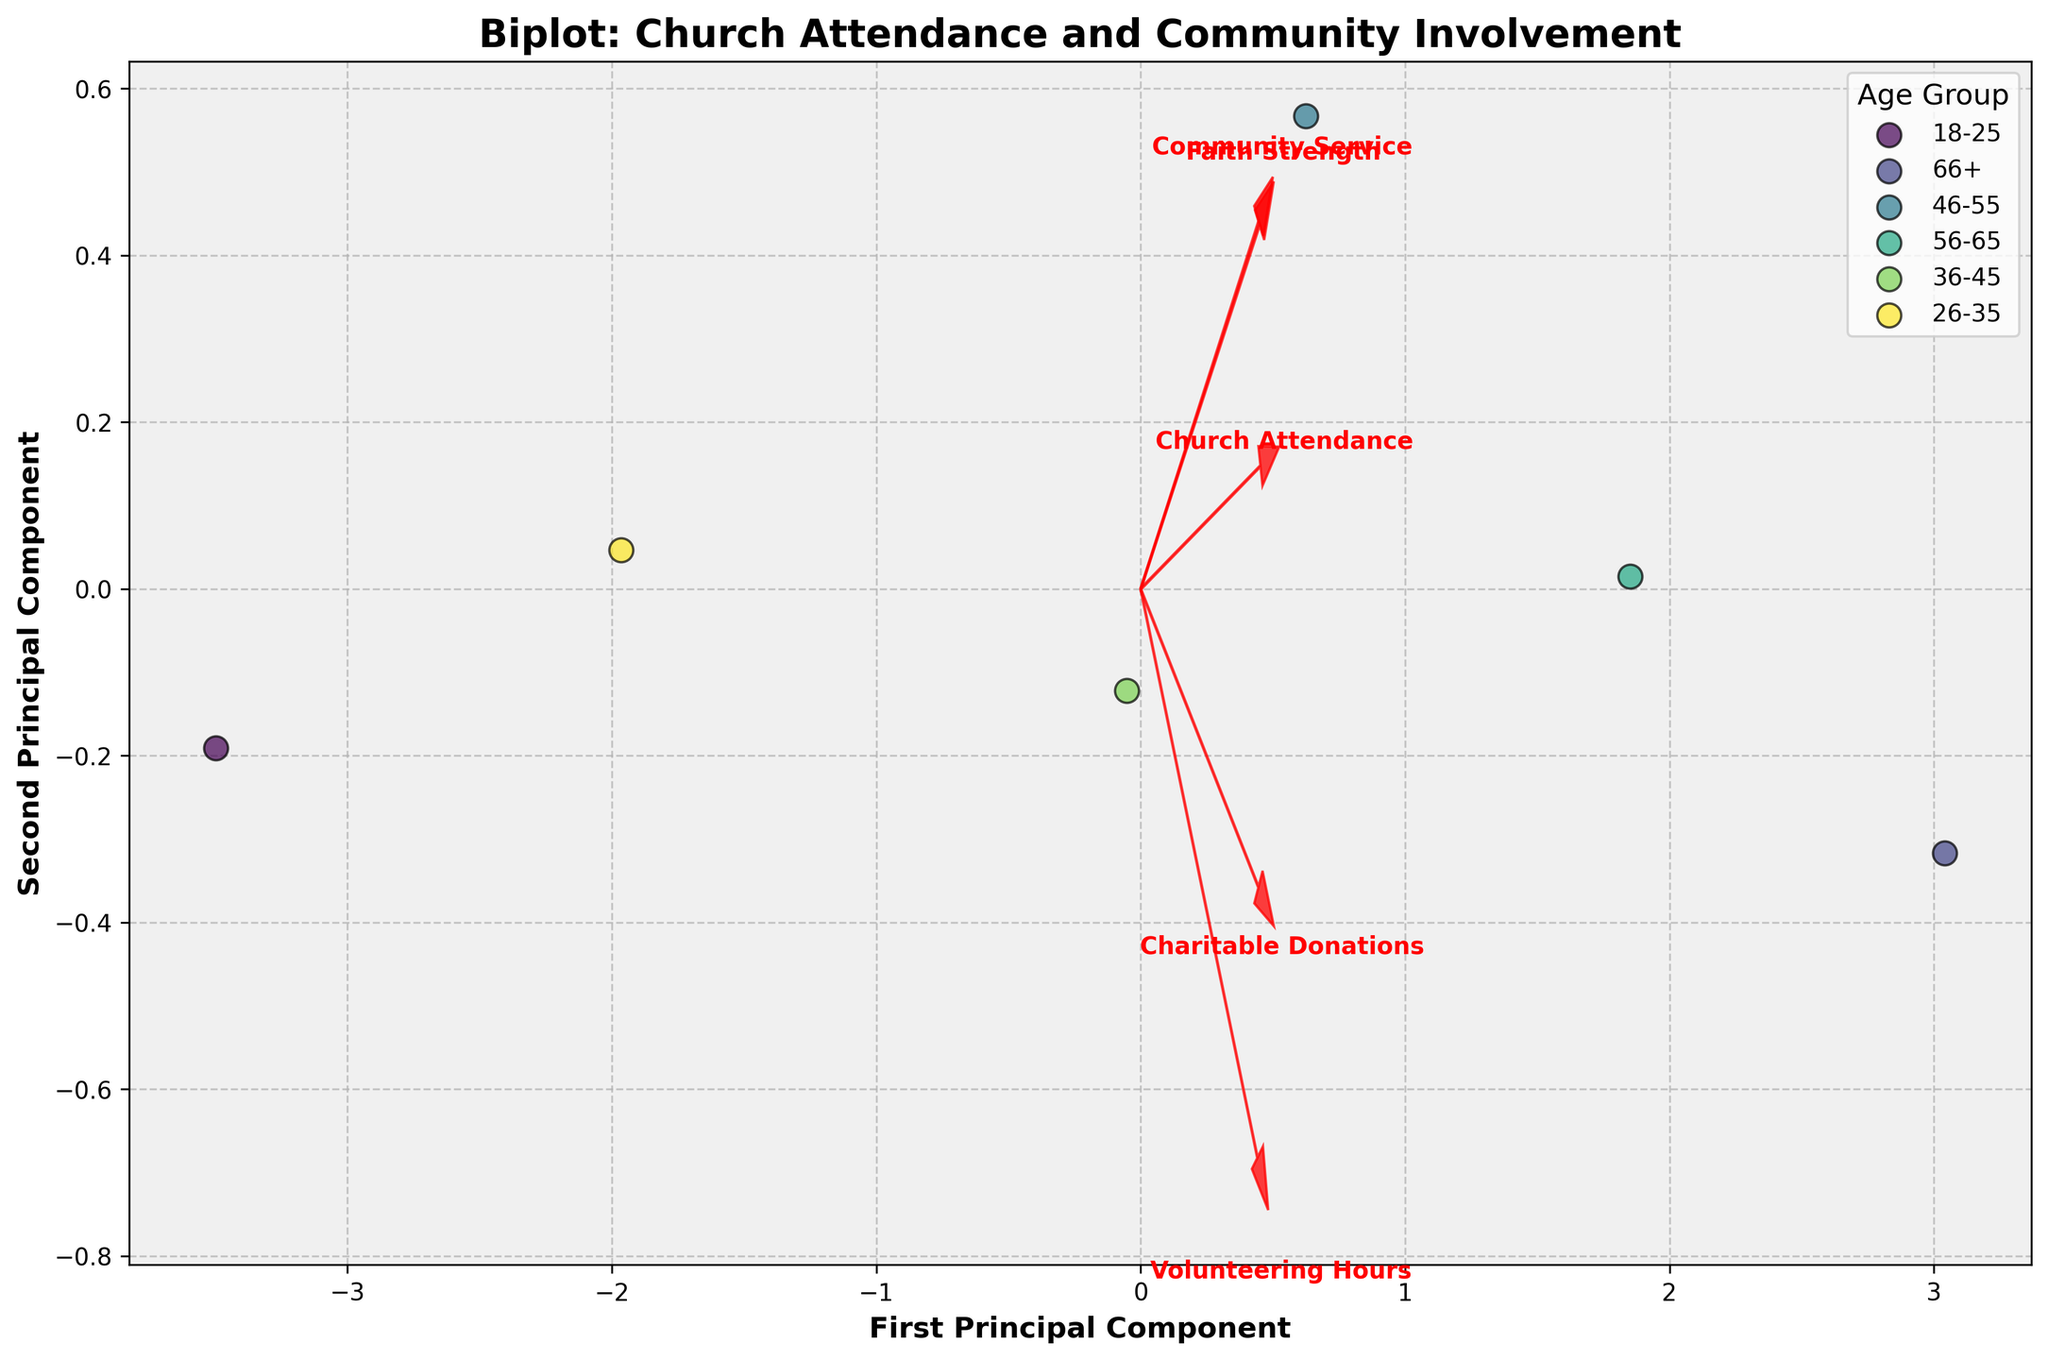What is the title of the figure? The title of the figure is given at the top of the plot. By looking at the top, you'll see that it clearly states the purpose of the visualization.
Answer: Biplot: Church Attendance and Community Involvement What are the axis labels in the figure? The axis labels are found on the horizontal and vertical axes of the plot. The horizontal axis label is for the first principal component, and the vertical axis label is for the second principal component.
Answer: First Principal Component (x-axis), Second Principal Component (y-axis) How many age groups are represented in the figure? The legend in the plot, usually represented at the side or bottom, lists the different age groups. By counting these groups, you can determine the total number of age groups present.
Answer: 6 Which age group has the highest values on the first principal component? To find this, we need to look at the horizontal spread of the data points for each age group. The age group with the farthest right scatter points on the X-axis has the highest values.
Answer: Age group 66+ Which feature is represented by the arrow pointing farthest to the right? The arrows (feature vectors) show how much each feature contributes to the principal components. The arrow pointing farthest to the right indicates the feature with the largest positive contribution to the first principal component.
Answer: Charitable Donations How do Church Attendance and Community Service relate to the first and second principal components? By looking at the direction and length of the arrows for Church Attendance and Community Service, we can interpret their influence on the principal components. Church Attendance has a longer arrow in the upper right direction indicating a strong positive influence on both components, whereas Community Service points slightly towards the top showing a moderate influence.
Answer: Strong positive relationship with both components for Church Attendance, moderate positive relationship with second component for Community Service What is the general trend observed in how age groups are distributed along the first principal component? Looking at the scatter of age groups from left to right along the X-axis (first principal component), we can deduce if there is a trend from younger to older age groups or any other pattern based on their positioning.
Answer: Older age groups generally have higher values along the first principal component Which feature has the least influence on the first principal component? The length and direction of the feature arrows help determine their influence. The feature with the shortest arrow in the horizontal direction has the least influence on the first principal component.
Answer: Faith Strength Between the 26-35 and 36-45 age groups, which shows higher values in both principal components? Observing the positions of the data points for these two age groups on both axes, the one higher on the Y-axis and further right on the X-axis represents higher values in both components.
Answer: 36-45 age group Does Volunteering Hours have a stronger influence on the first or second principal component? The direction and length of the Volunteering Hours arrow relative to both axes tell us about its strength on each principal component. If the arrow leans more towards one axis, it has a stronger influence there.
Answer: Second principal component 